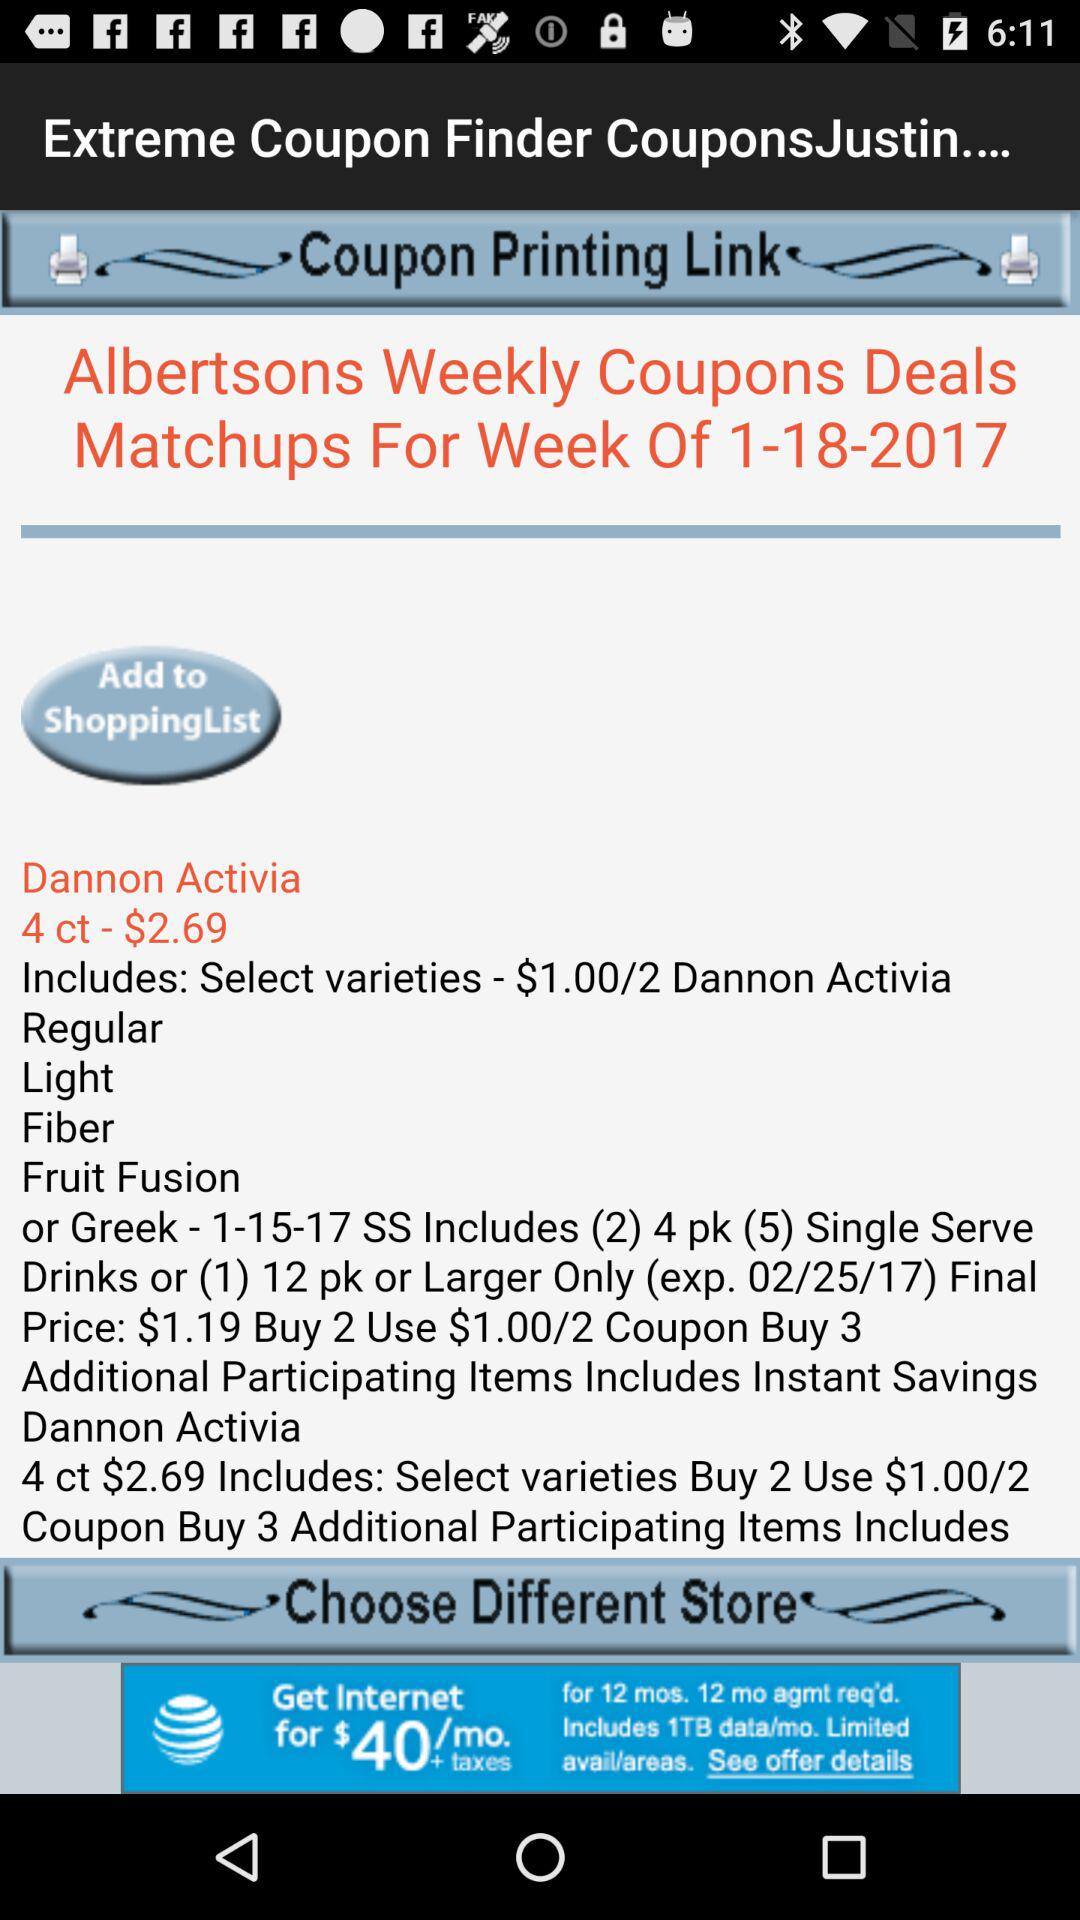When were the Albertsons weekly coupon deals held? The coupon deals were held on January 18, 2017. 